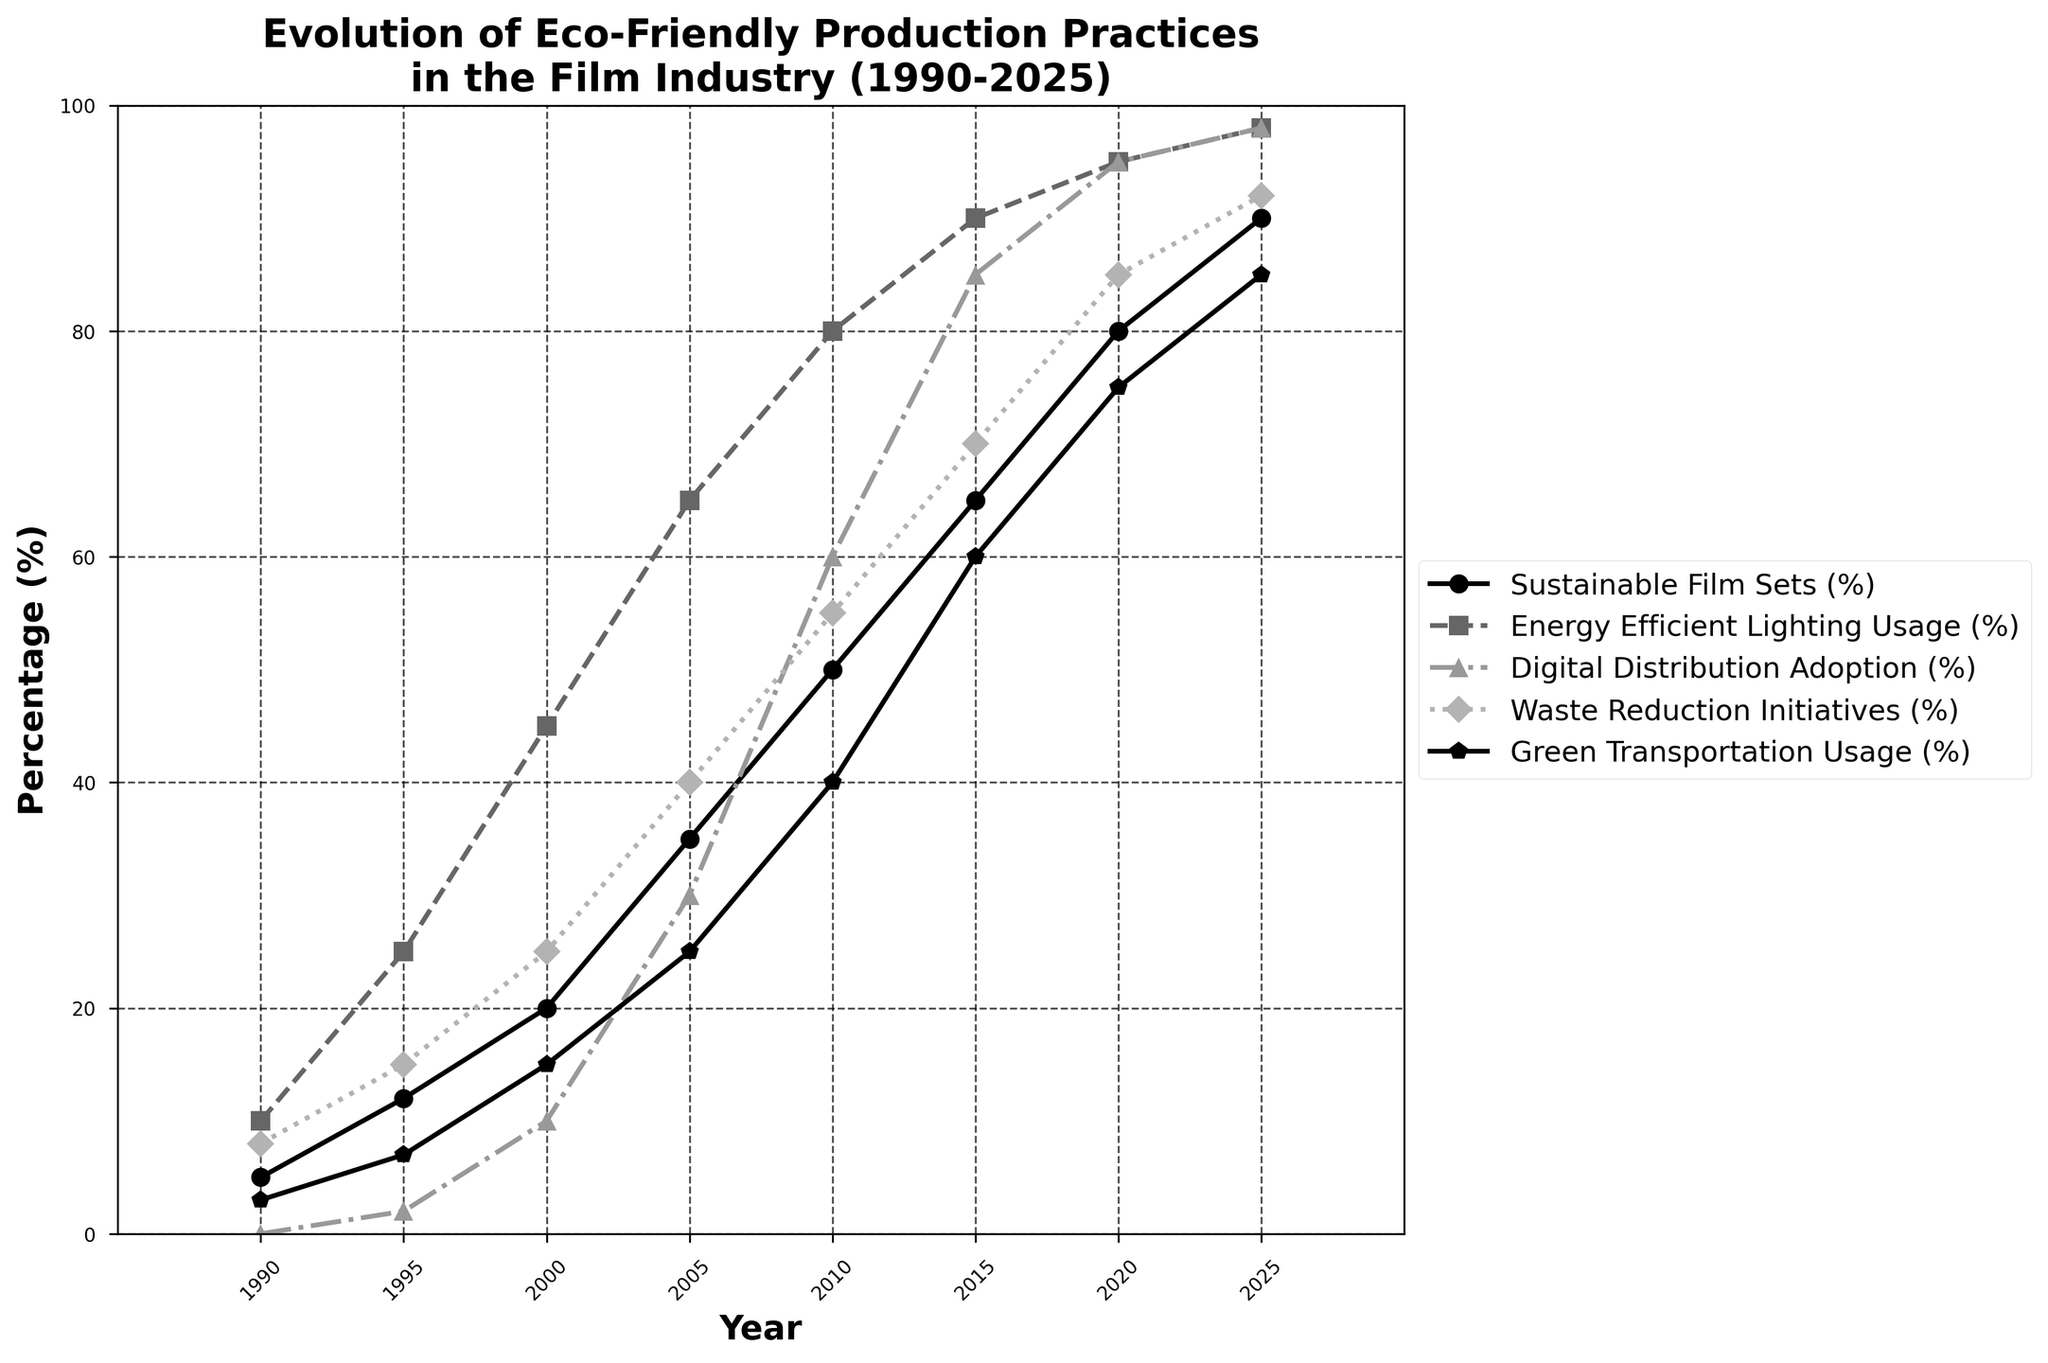What percentage of Sustainable Film Sets was achieved in 2005? From the chart, locate the year 2005 on the x-axis and follow it vertically until intersecting the Sustainable Film Sets line. The value is 35%.
Answer: 35% Compare the adoption rates of Digital Distribution between 2010 and 2015. Which year had higher adoption, and by how much? From the chart, find the values for Digital Distribution in 2010 and 2015. In 2010, it was 60%, and in 2015, it was 85%. The difference is 85 - 60 = 25%.
Answer: 2015 by 25% Among the years given, in which year did Green Transportation Usage see its most significant percentage increase from the previous recorded value? Check the increase between each consecutive year for Green Transportation Usage. The biggest jump is from 15% in 2000 to 25% in 2005, an increase of 10%.
Answer: 2005 What is the trend in Energy Efficient Lighting Usage from 1990 to 2025? The chart shows a consistent upward trend in Energy Efficient Lighting Usage from 10% in 1990 to 98% in 2025.
Answer: Upward trend Calculate the average percentage of Waste Reduction Initiatives for the years provided. Sum the percentages for Waste Reduction Initiatives: (8 + 15 + 25 + 40 + 55 + 70 + 85 + 92) = 390. Then divide by the number of years, which is 8. Average = 390/8 = 48.75.
Answer: 48.75 Between Energy Efficient Lighting Usage and Green Transportation Usage in 2020, which had a higher percentage, and by how much? In 2020, Energy Efficient Lighting Usage is 95% and Green Transportation Usage is 75%. The difference is 95 - 75 = 20%.
Answer: Energy Efficient Lighting Usage by 20% Which year showed the introduction of Digital Distribution, and what was the initial percentage? The chart indicates Digital Distribution starts being recorded in 1995 with an initial percentage of 2%.
Answer: 1995, 2% Is there any year where all five categories are over 50%? Check each year: 2010 is the first year where all values exceed 50%. The values are 50% (Sustainable Film Sets), 80% (Energy Efficient Lighting Usage), 60% (Digital Distribution Adoption), 55% (Waste Reduction Initiatives), and 40% (Green Transportation Usage).
Answer: No How does the percentage of Sustainable Film Sets in 2025 compare to Energy Efficient Lighting Usage in 2005? Sustainable Film Sets in 2025 is 90% while Energy Efficient Lighting Usage in 2005 is 65%. 90 is greater than 65.
Answer: Sustainable Film Sets in 2025 is greater by 25% What percentage gap exists between Sustainable Film Sets and Green Transportation Usage in 1990? In 1990, Sustainable Film Sets is 5% and Green Transportation Usage is 3%. The gap is 5 - 3 = 2%.
Answer: 2% 